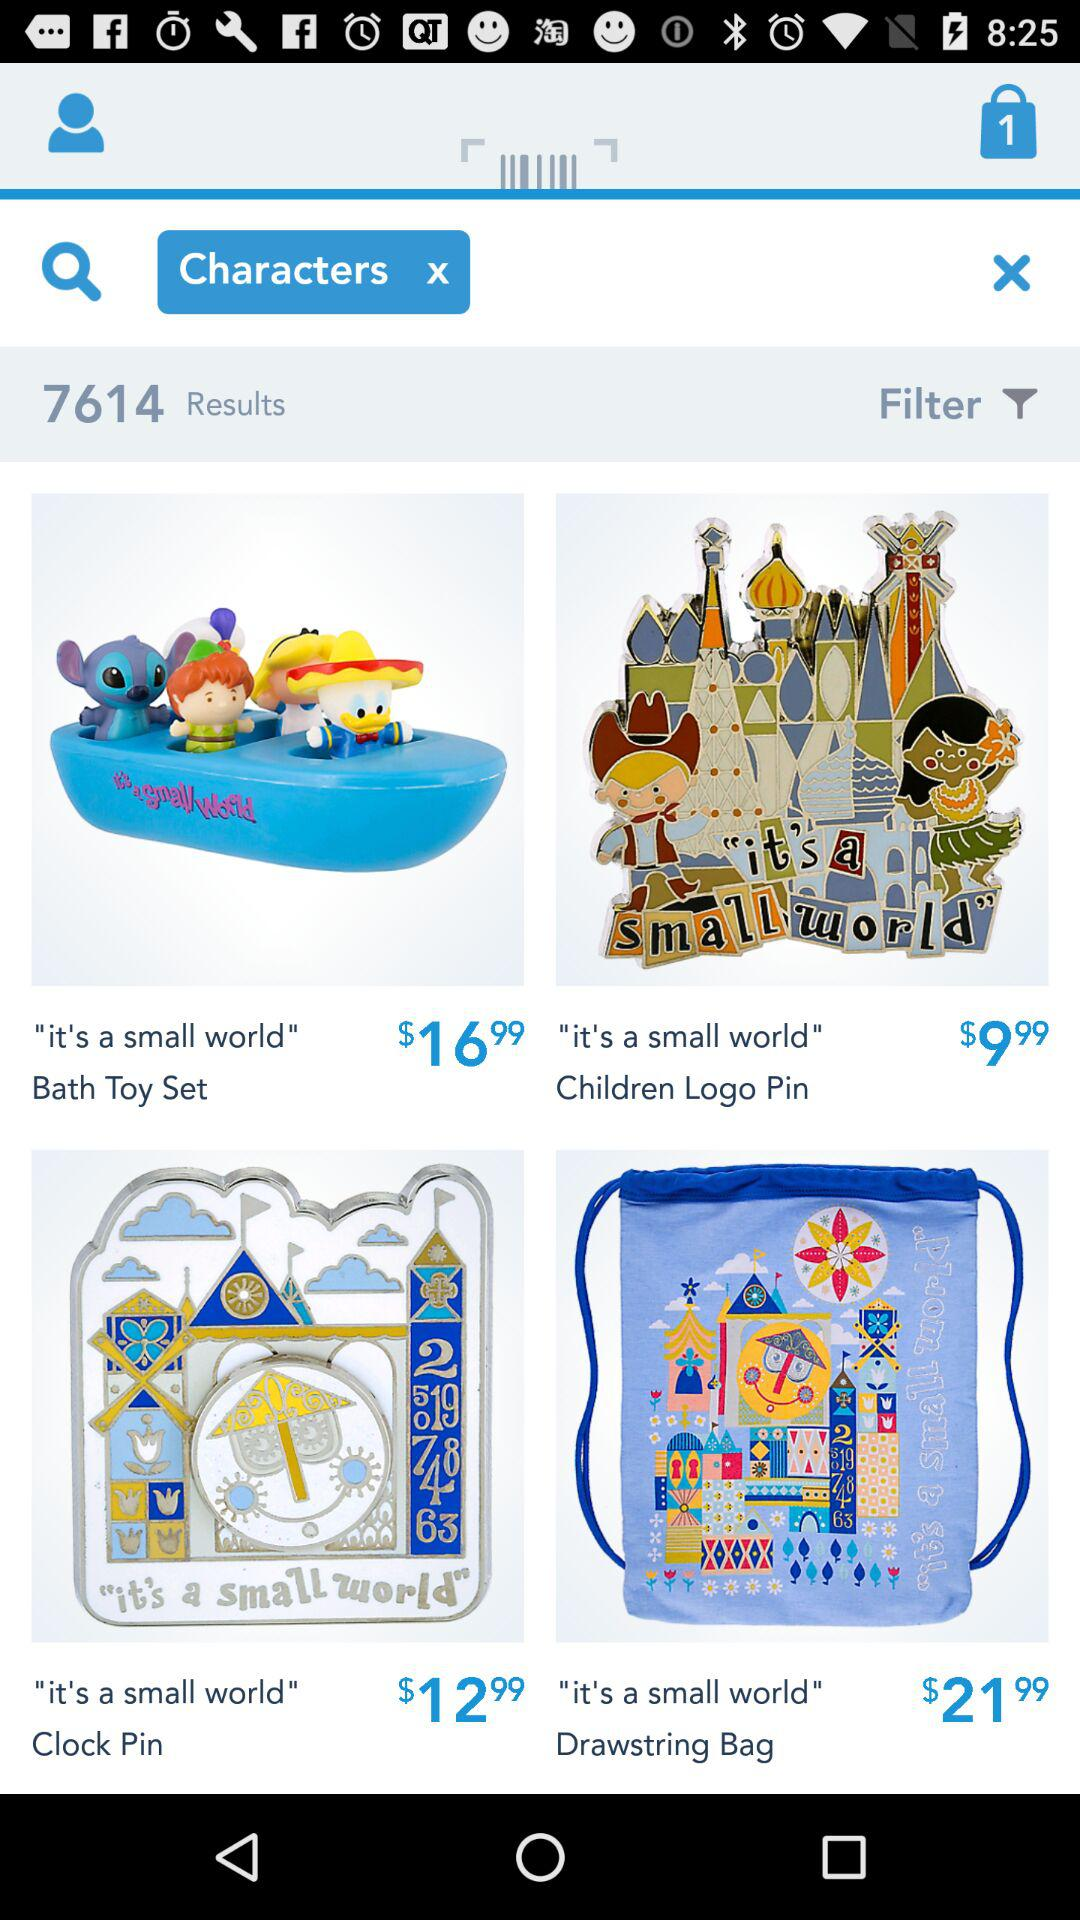How many items have a price of more than $10.00?
Answer the question using a single word or phrase. 3 